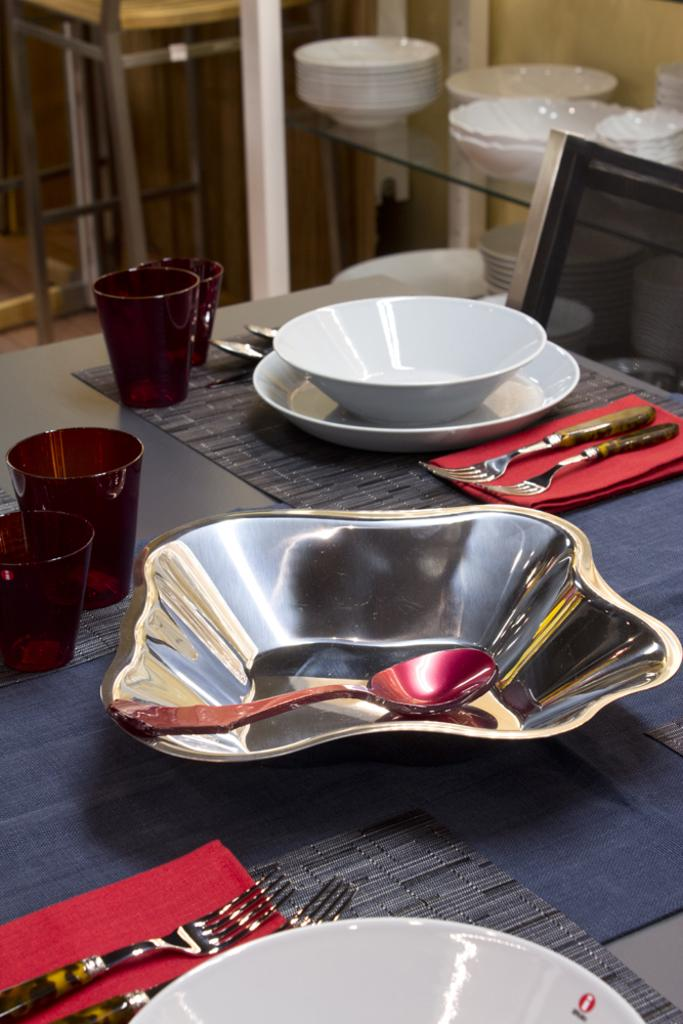What is present in the image that can hold food? There is a bowl in the image. What is inside the bowl? There is a spoon in the bowl. What other items can be seen in the image that are used for eating or serving food? There are glasses and a plate in the image. How is the bowl positioned in relation to the plate? There is a bowl on the plate. What utensils are present on the cloth in the image? There are two forks on the cloth. What type of spark can be seen coming from the bowl in the image? There is no spark present in the image; it is a bowl with a spoon inside. 